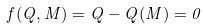<formula> <loc_0><loc_0><loc_500><loc_500>f ( Q , M ) = Q - Q ( M ) = 0</formula> 